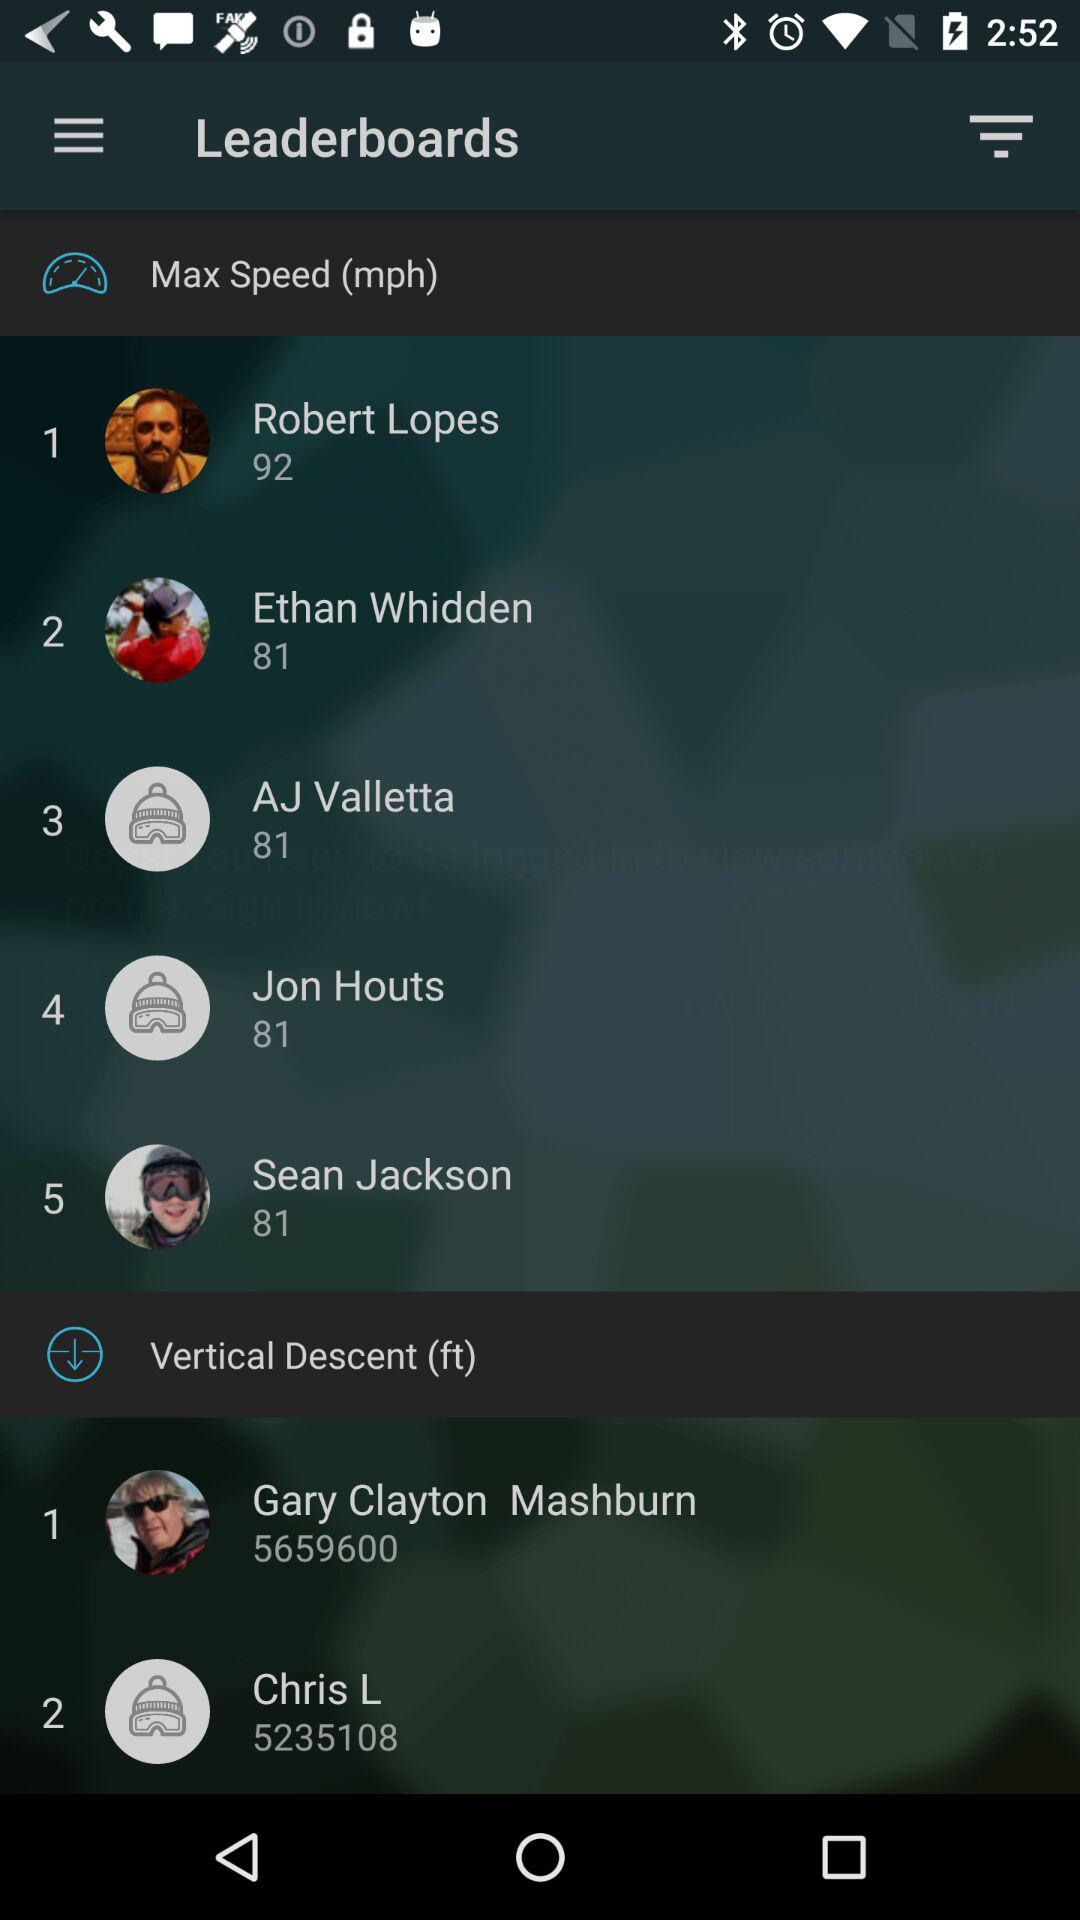What is the maximum speed of Jon Houts? The maximum speed of Jon Houts is 81 mph. 